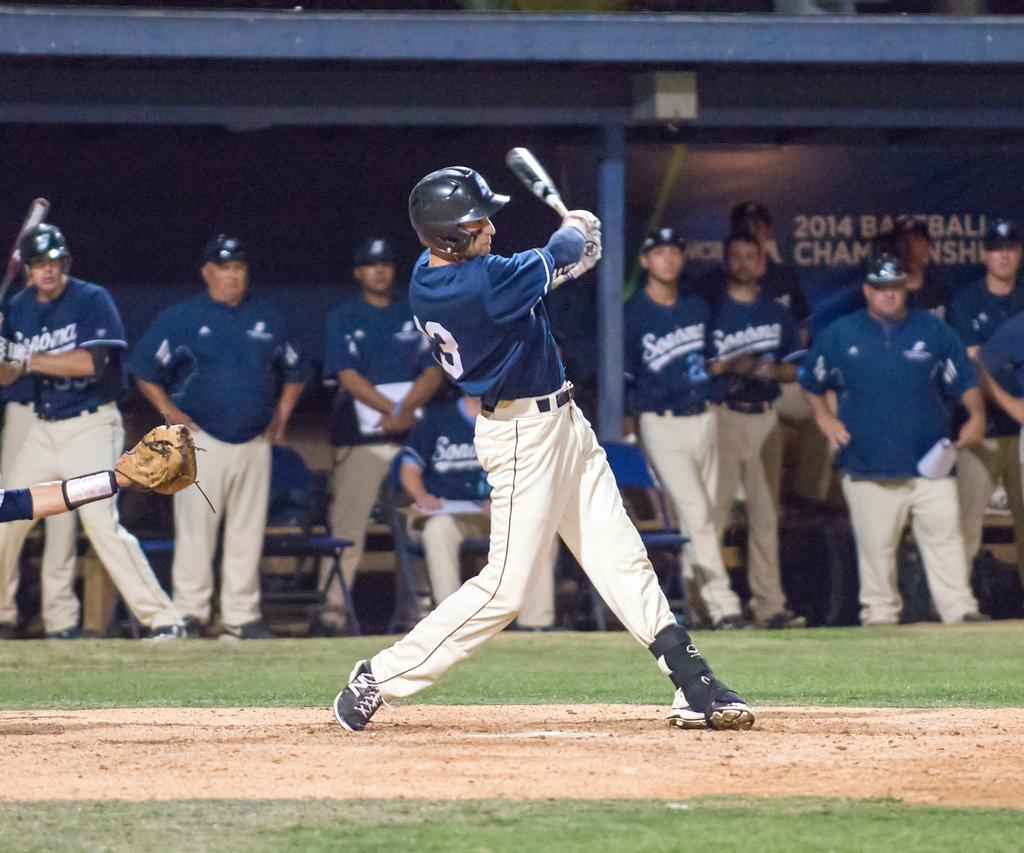<image>
Describe the image concisely. Baseball championship game of 2014 showing the Seahawks at bat. 